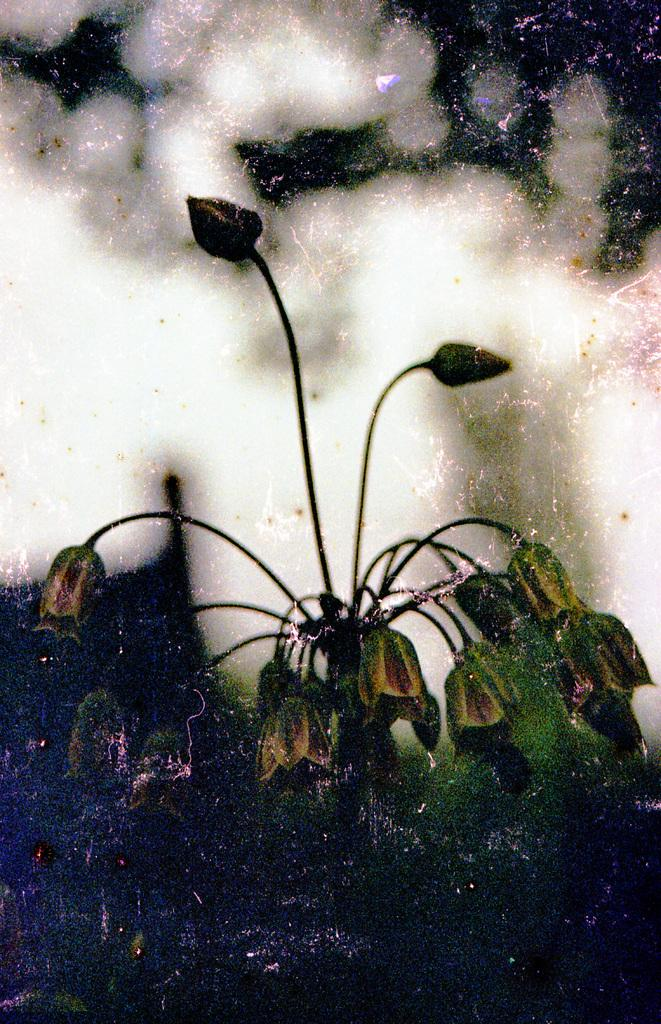What is the main subject of the picture? There is a plant in the picture. Can you describe the background of the image? The background of the image is blurred. What type of land can be seen in the background of the image? There is no land visible in the image, as the background is blurred. What color is the skirt worn by the plant in the image? There is no skirt present in the image, as it features a plant and not a person. 